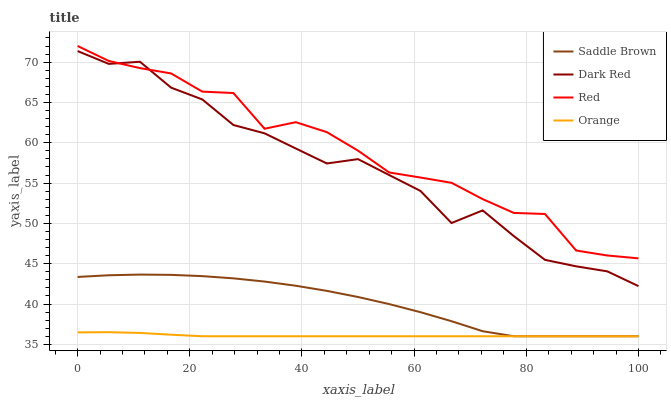Does Orange have the minimum area under the curve?
Answer yes or no. Yes. Does Red have the maximum area under the curve?
Answer yes or no. Yes. Does Dark Red have the minimum area under the curve?
Answer yes or no. No. Does Dark Red have the maximum area under the curve?
Answer yes or no. No. Is Orange the smoothest?
Answer yes or no. Yes. Is Dark Red the roughest?
Answer yes or no. Yes. Is Saddle Brown the smoothest?
Answer yes or no. No. Is Saddle Brown the roughest?
Answer yes or no. No. Does Orange have the lowest value?
Answer yes or no. Yes. Does Dark Red have the lowest value?
Answer yes or no. No. Does Red have the highest value?
Answer yes or no. Yes. Does Dark Red have the highest value?
Answer yes or no. No. Is Orange less than Dark Red?
Answer yes or no. Yes. Is Dark Red greater than Orange?
Answer yes or no. Yes. Does Dark Red intersect Red?
Answer yes or no. Yes. Is Dark Red less than Red?
Answer yes or no. No. Is Dark Red greater than Red?
Answer yes or no. No. Does Orange intersect Dark Red?
Answer yes or no. No. 